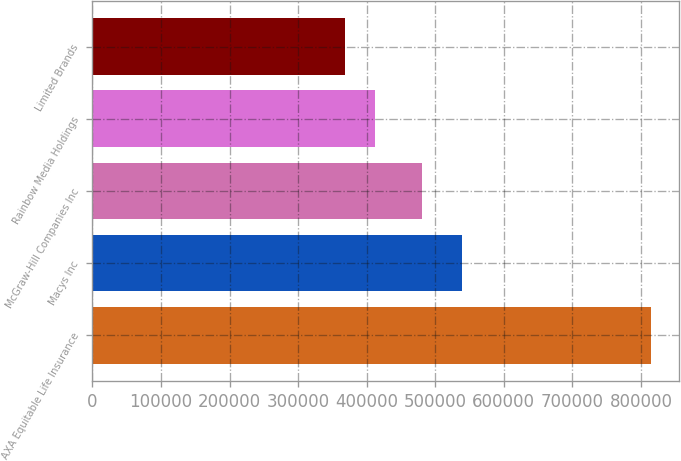Convert chart to OTSL. <chart><loc_0><loc_0><loc_500><loc_500><bar_chart><fcel>AXA Equitable Life Insurance<fcel>Macys Inc<fcel>McGraw-Hill Companies Inc<fcel>Rainbow Media Holdings<fcel>Limited Brands<nl><fcel>815000<fcel>539000<fcel>480000<fcel>412700<fcel>368000<nl></chart> 